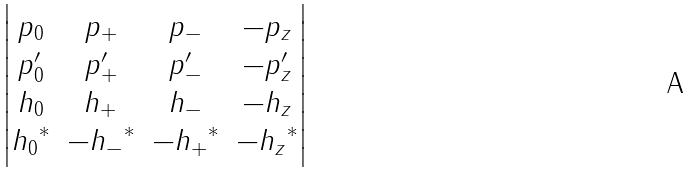Convert formula to latex. <formula><loc_0><loc_0><loc_500><loc_500>\begin{vmatrix} p _ { 0 } & p _ { + } & p _ { - } & - p _ { z } \\ p ^ { \prime } _ { 0 } & p ^ { \prime } _ { + } & p ^ { \prime } _ { - } & - p ^ { \prime } _ { z } \\ h _ { 0 } & h _ { + } & h _ { - } & - h _ { z } \\ { h _ { 0 } } ^ { * } & - { h _ { - } } ^ { * } & - { h _ { + } } ^ { * } & - { h _ { z } } ^ { * } \end{vmatrix}</formula> 